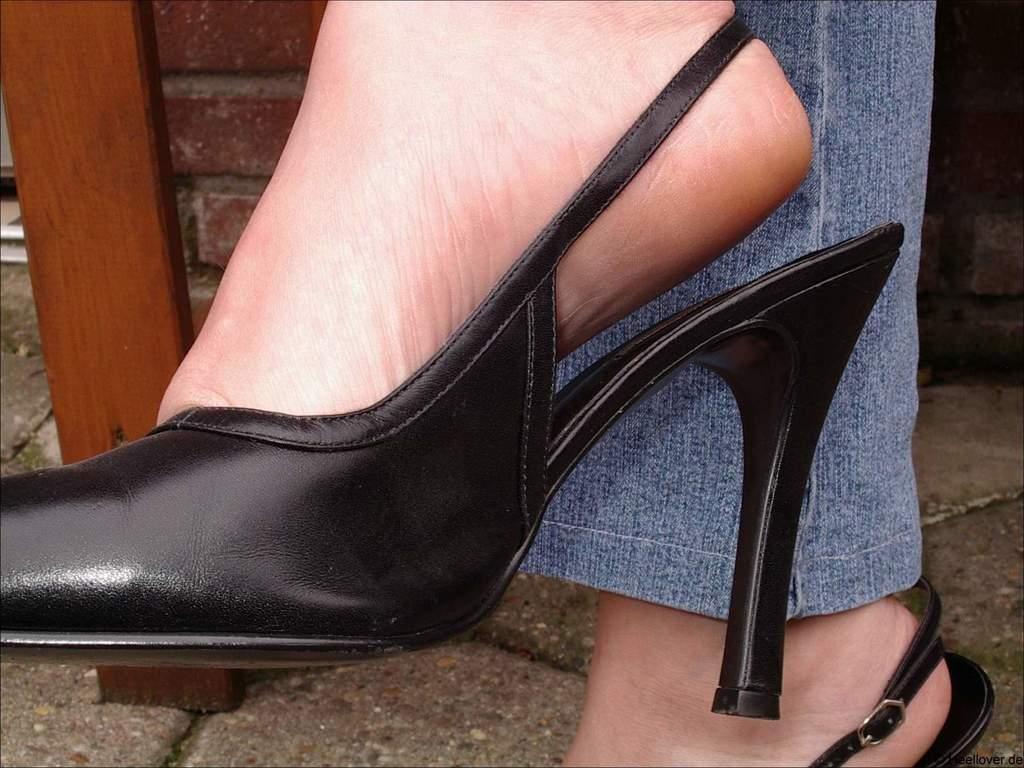How would you summarize this image in a sentence or two? In this image we can see a person's feet wearing black sandals. 